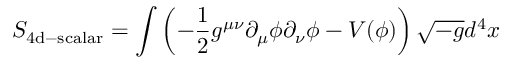<formula> <loc_0><loc_0><loc_500><loc_500>S _ { 4 d - s c a l a r } = \int { \left ( - { \frac { 1 } { 2 } } g ^ { \mu \nu } \partial _ { \mu } \phi \partial _ { \nu } \phi - V ( \phi ) \right ) \sqrt { - g } d ^ { 4 } x }</formula> 